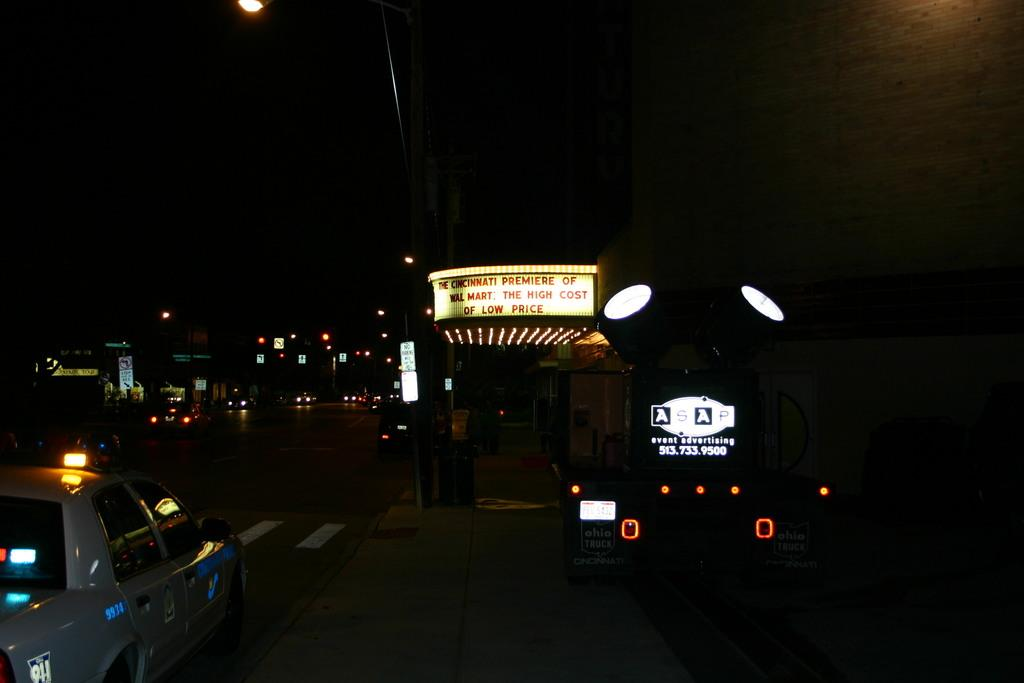<image>
Summarize the visual content of the image. A Cincinnati premier is advertised on a large, lit sign. 